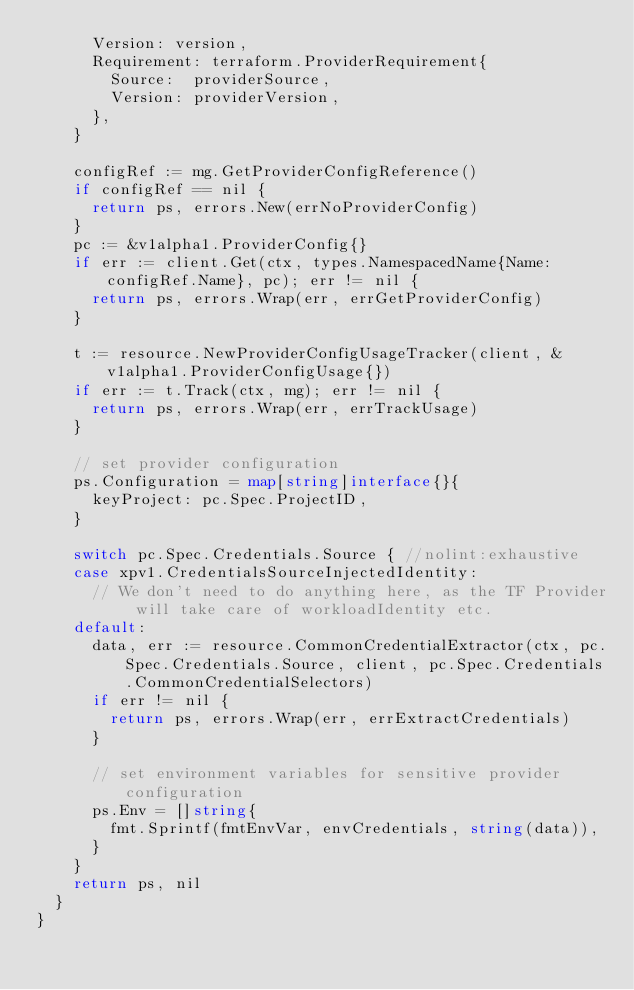Convert code to text. <code><loc_0><loc_0><loc_500><loc_500><_Go_>			Version: version,
			Requirement: terraform.ProviderRequirement{
				Source:  providerSource,
				Version: providerVersion,
			},
		}

		configRef := mg.GetProviderConfigReference()
		if configRef == nil {
			return ps, errors.New(errNoProviderConfig)
		}
		pc := &v1alpha1.ProviderConfig{}
		if err := client.Get(ctx, types.NamespacedName{Name: configRef.Name}, pc); err != nil {
			return ps, errors.Wrap(err, errGetProviderConfig)
		}

		t := resource.NewProviderConfigUsageTracker(client, &v1alpha1.ProviderConfigUsage{})
		if err := t.Track(ctx, mg); err != nil {
			return ps, errors.Wrap(err, errTrackUsage)
		}

		// set provider configuration
		ps.Configuration = map[string]interface{}{
			keyProject: pc.Spec.ProjectID,
		}

		switch pc.Spec.Credentials.Source { //nolint:exhaustive
		case xpv1.CredentialsSourceInjectedIdentity:
			// We don't need to do anything here, as the TF Provider will take care of workloadIdentity etc.
		default:
			data, err := resource.CommonCredentialExtractor(ctx, pc.Spec.Credentials.Source, client, pc.Spec.Credentials.CommonCredentialSelectors)
			if err != nil {
				return ps, errors.Wrap(err, errExtractCredentials)
			}

			// set environment variables for sensitive provider configuration
			ps.Env = []string{
				fmt.Sprintf(fmtEnvVar, envCredentials, string(data)),
			}
		}
		return ps, nil
	}
}
</code> 